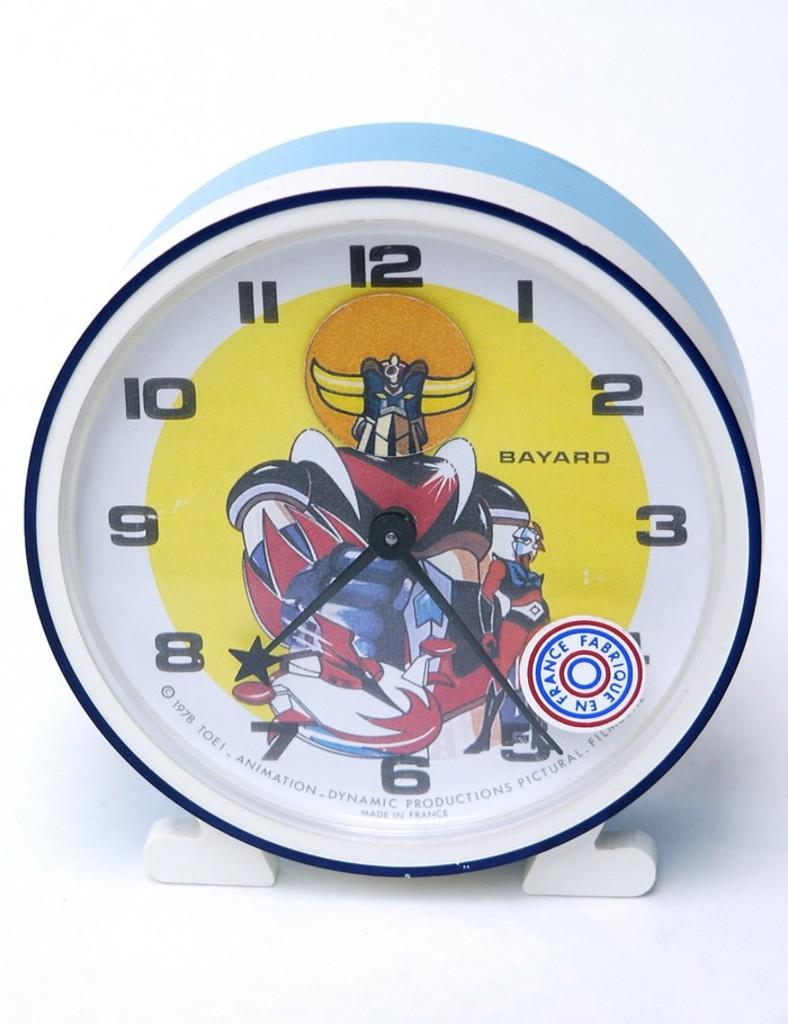<image>
Provide a brief description of the given image. Clock from Bayard that is white, black, and blue 